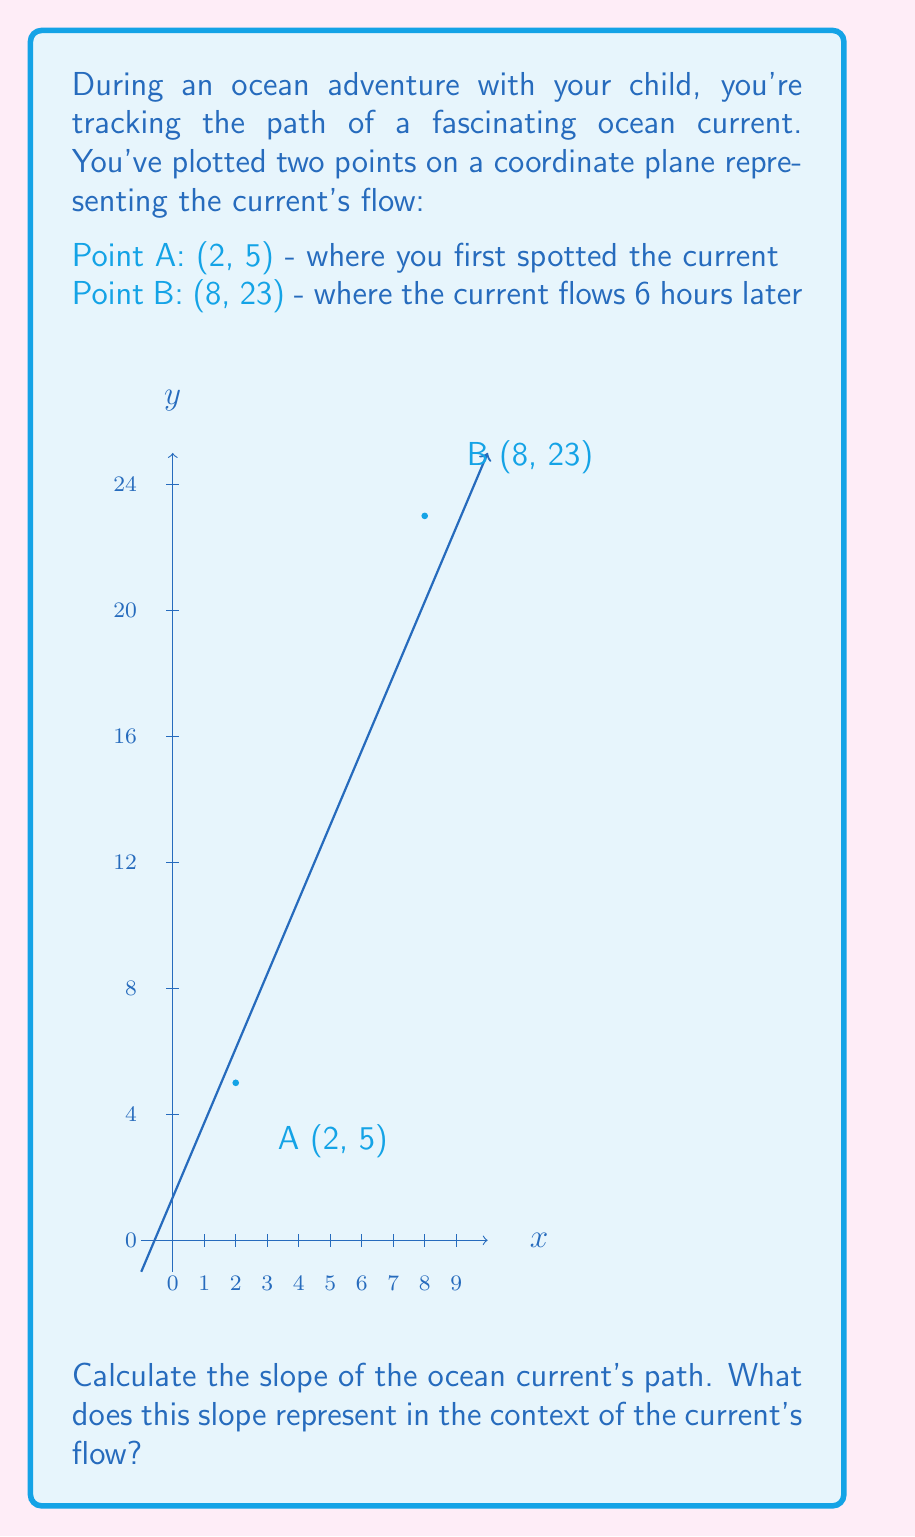Solve this math problem. Let's approach this step-by-step:

1) The slope formula is:

   $$m = \frac{y_2 - y_1}{x_2 - x_1}$$

   where $(x_1, y_1)$ is the first point and $(x_2, y_2)$ is the second point.

2) We have:
   Point A: $(x_1, y_1) = (2, 5)$
   Point B: $(x_2, y_2) = (8, 23)$

3) Let's substitute these into our slope formula:

   $$m = \frac{23 - 5}{8 - 2} = \frac{18}{6}$$

4) Simplify:

   $$m = 3$$

5) Interpretation: The slope represents the rate of change in the y-coordinate (vertical distance) with respect to the x-coordinate (horizontal distance). In this context:

   - The y-axis could represent the distance traveled by the current in nautical miles.
   - The x-axis could represent time in hours.

   So, a slope of 3 means that for every 1 unit increase in x (1 hour), y increases by 3 units (3 nautical miles).

6) Therefore, the ocean current is flowing at a rate of 3 nautical miles per hour.
Answer: $m = 3$; The current flows at 3 nautical miles per hour. 